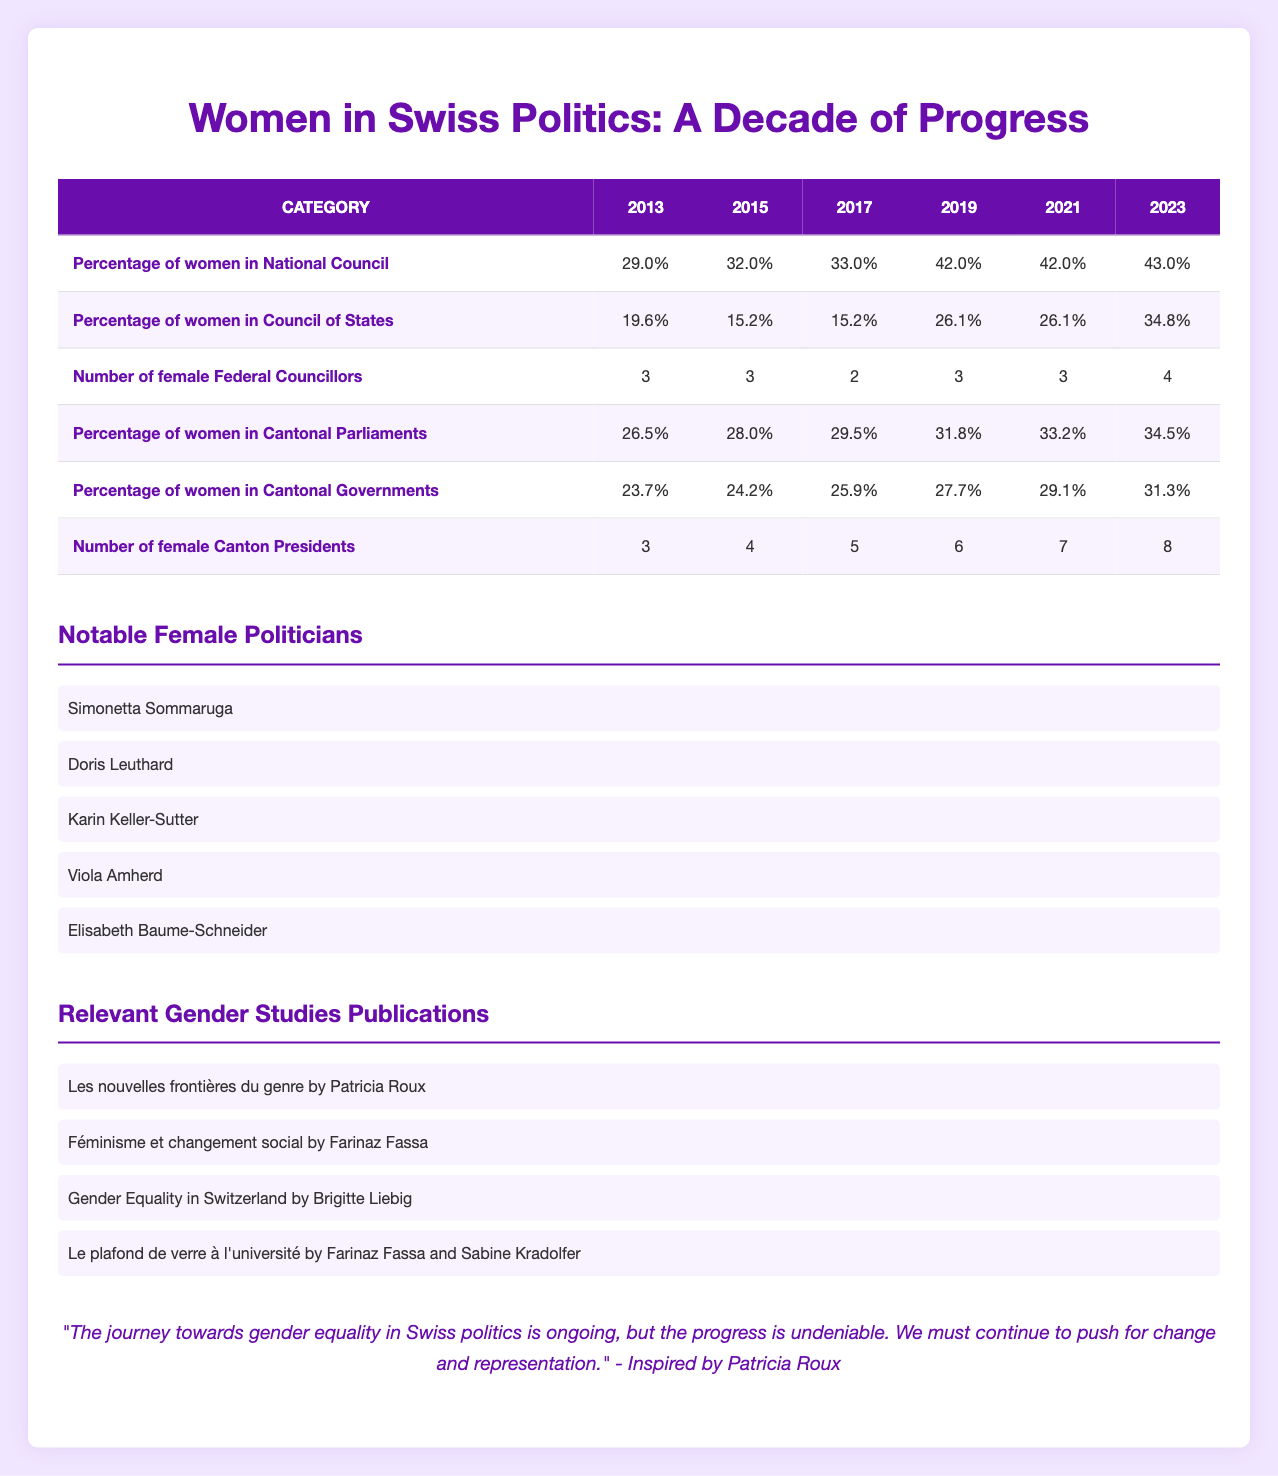What was the percentage of women in the National Council in 2021? Referring directly to the table under the "Percentage of women in National Council" category for the year 2021, the value listed is 42.0%.
Answer: 42.0% Was there an increase in the percentage of women in the Council of States from 2017 to 2019? To find this, we compare the values for 2017 (15.2%) and 2019 (26.1%) from the table. Since 26.1% is greater than 15.2%, there was indeed an increase.
Answer: Yes What is the average percentage of women in Cantonal Governments from 2013 to 2023? To calculate the average, first sum the percentages: 23.7 + 24.2 + 25.9 + 27.7 + 29.1 + 31.3 = 161.9. Then, divide by the number of years (6). Therefore, 161.9 / 6 = 26.98%.
Answer: 26.98% In which year did the highest percentage of women in the National Council occur? Checking the values under "Percentage of women in National Council," the highest value is 43.0%, which appears in 2023.
Answer: 2023 Was there a consistent upward trend in the number of female Canton Presidents from 2013 to 2023? Examining the data from the "Number of female Canton Presidents" column, we see the values increase from 3 in 2013 to 8 in 2023. This indicates a consistent upward trend.
Answer: Yes What was the difference in the percentage of women in Cantonal Parliaments from 2013 to 2023? The value for 2013 is 26.5% and for 2023 is 34.5%. To find the difference, subtract the two: 34.5 - 26.5 = 8.0%.
Answer: 8.0% What was the number of female Federal Councillors in 2015? The table indicates there were 3 female Federal Councillors in 2015, found directly under that category and year.
Answer: 3 How many more percentage points did the percentage of women in Cantonal Governments rise from 2019 to 2021? The percentage for 2019 is 27.7% and for 2021 it is 29.1%. The difference is calculated as 29.1 - 27.7 = 1.4 percentage points.
Answer: 1.4% What was the lowest percentage of women in the Council of States recorded and in which year? The lowest percentage recorded in the "Percentage of women in Council of States" category is 15.2%, occurring in both 2015 and 2017.
Answer: 15.2%, 2015 and 2017 